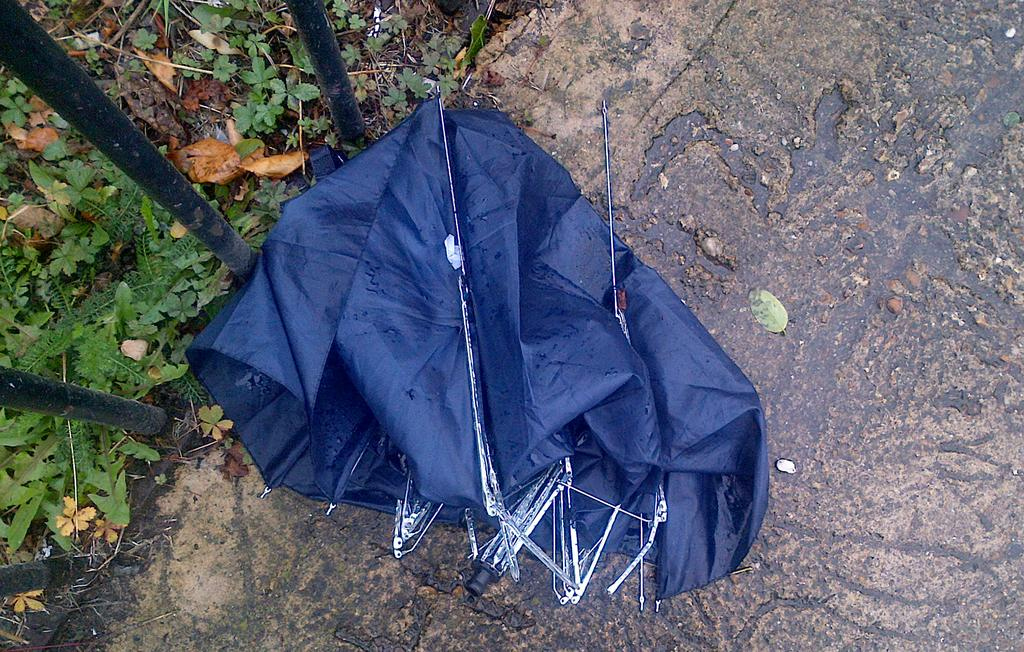What object is broken in the image? There is a broken umbrella in the image. What is the color of the broken umbrella? The umbrella is black in color. Where is the broken umbrella located? The umbrella is on the floor. What type of surface is visible in the image? There is grass visible in the image. What type of material is used for the metal rods in the image? The metal rods in the image are made of metal. How many rings can be seen on the seat in the image? There is no seat present in the image, and therefore no rings can be observed. 